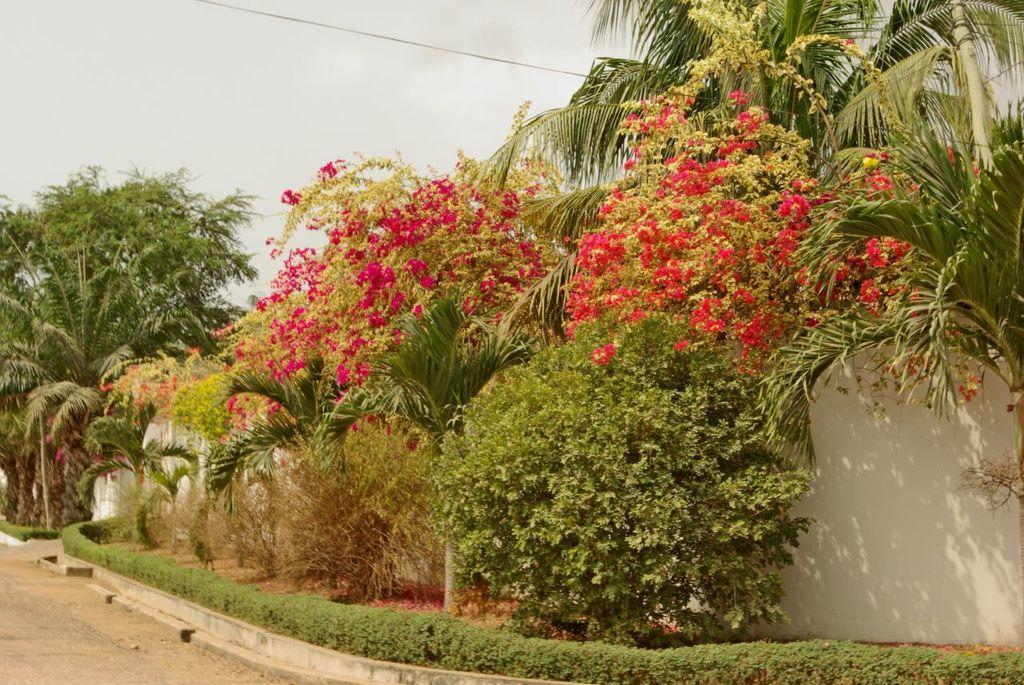Could you give a brief overview of what you see in this image? In this picture there are flower plants and trees in the image, there is boundary wall in the image. 